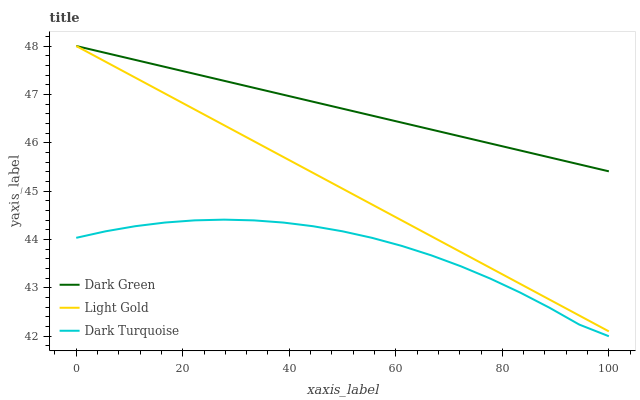Does Dark Turquoise have the minimum area under the curve?
Answer yes or no. Yes. Does Dark Green have the maximum area under the curve?
Answer yes or no. Yes. Does Light Gold have the minimum area under the curve?
Answer yes or no. No. Does Light Gold have the maximum area under the curve?
Answer yes or no. No. Is Light Gold the smoothest?
Answer yes or no. Yes. Is Dark Turquoise the roughest?
Answer yes or no. Yes. Is Dark Green the smoothest?
Answer yes or no. No. Is Dark Green the roughest?
Answer yes or no. No. Does Dark Turquoise have the lowest value?
Answer yes or no. Yes. Does Light Gold have the lowest value?
Answer yes or no. No. Does Dark Green have the highest value?
Answer yes or no. Yes. Is Dark Turquoise less than Dark Green?
Answer yes or no. Yes. Is Dark Green greater than Dark Turquoise?
Answer yes or no. Yes. Does Dark Green intersect Light Gold?
Answer yes or no. Yes. Is Dark Green less than Light Gold?
Answer yes or no. No. Is Dark Green greater than Light Gold?
Answer yes or no. No. Does Dark Turquoise intersect Dark Green?
Answer yes or no. No. 